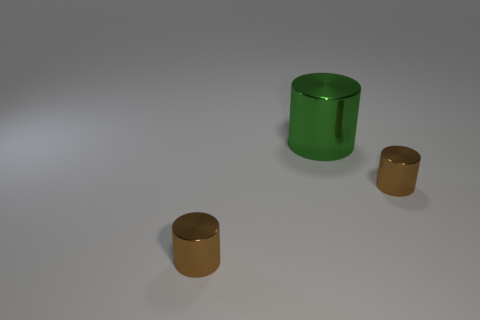Do the large thing and the cylinder that is to the left of the large green cylinder have the same material?
Provide a short and direct response. Yes. Are any big red metallic cylinders visible?
Provide a succinct answer. No. There is a brown metallic object behind the object that is to the left of the green metallic cylinder; is there a small brown object behind it?
Your answer should be compact. No. What number of big objects are either brown things or cylinders?
Make the answer very short. 1. How many brown metal objects are in front of the green shiny cylinder?
Keep it short and to the point. 2. Is there another big cylinder made of the same material as the green cylinder?
Keep it short and to the point. No. What is the color of the tiny thing on the left side of the green cylinder?
Provide a short and direct response. Brown. There is a tiny brown cylinder that is on the left side of the small metal cylinder on the right side of the large shiny object; what is its material?
Ensure brevity in your answer.  Metal. How many objects are brown metallic cylinders or cylinders that are in front of the green cylinder?
Provide a short and direct response. 2. Are there more tiny brown things on the left side of the large object than brown shiny objects?
Your answer should be very brief. No. 